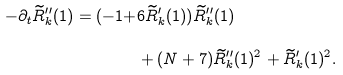<formula> <loc_0><loc_0><loc_500><loc_500>- \partial _ { t } \widetilde { R } _ { k } ^ { \prime \prime } ( 1 ) = ( - 1 + & 6 \widetilde { R } _ { k } ^ { \prime } ( 1 ) ) \widetilde { R } _ { k } ^ { \prime \prime } ( 1 ) \\ & + ( N + 7 ) \widetilde { R } _ { k } ^ { \prime \prime } ( 1 ) ^ { 2 } + \widetilde { R } _ { k } ^ { \prime } ( 1 ) ^ { 2 } .</formula> 